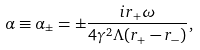<formula> <loc_0><loc_0><loc_500><loc_500>\alpha \equiv \alpha _ { \pm } = \pm \frac { i r _ { + } \omega } { 4 \gamma ^ { 2 } \Lambda ( r _ { + } - r _ { - } ) } ,</formula> 